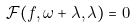<formula> <loc_0><loc_0><loc_500><loc_500>\mathcal { F } ( f , \omega + \lambda , \lambda ) = 0</formula> 